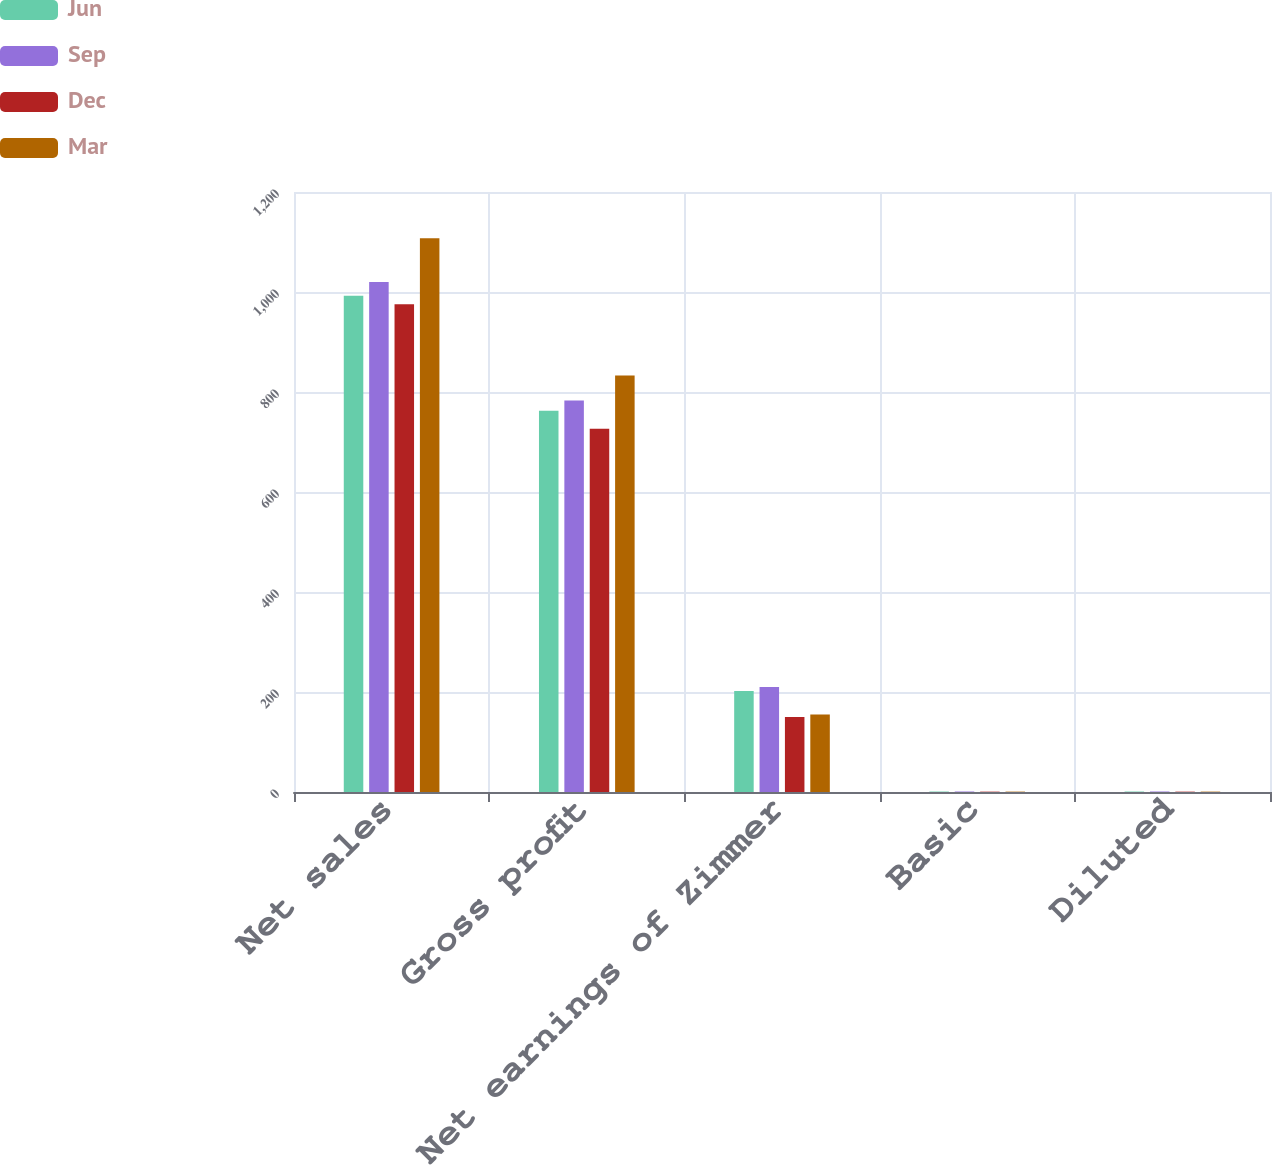<chart> <loc_0><loc_0><loc_500><loc_500><stacked_bar_chart><ecel><fcel>Net sales<fcel>Gross profit<fcel>Net earnings of Zimmer<fcel>Basic<fcel>Diluted<nl><fcel>Jun<fcel>992.6<fcel>762.3<fcel>202.2<fcel>0.91<fcel>0.91<nl><fcel>Sep<fcel>1019.9<fcel>783.1<fcel>210.1<fcel>0.98<fcel>0.98<nl><fcel>Dec<fcel>975.6<fcel>726.3<fcel>149.9<fcel>0.7<fcel>0.7<nl><fcel>Mar<fcel>1107.3<fcel>832.9<fcel>155.2<fcel>0.74<fcel>0.74<nl></chart> 